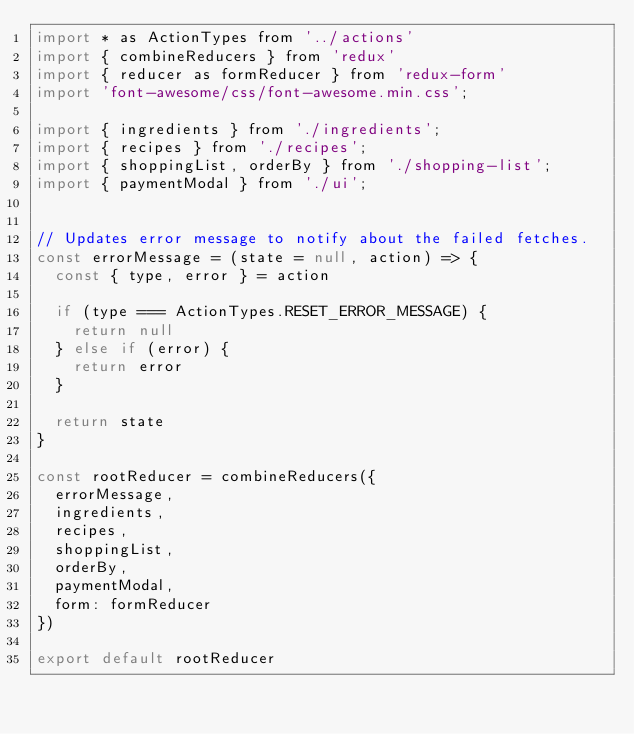<code> <loc_0><loc_0><loc_500><loc_500><_JavaScript_>import * as ActionTypes from '../actions'
import { combineReducers } from 'redux'
import { reducer as formReducer } from 'redux-form'
import 'font-awesome/css/font-awesome.min.css';

import { ingredients } from './ingredients';
import { recipes } from './recipes';
import { shoppingList, orderBy } from './shopping-list';
import { paymentModal } from './ui';


// Updates error message to notify about the failed fetches.
const errorMessage = (state = null, action) => {
  const { type, error } = action

  if (type === ActionTypes.RESET_ERROR_MESSAGE) {
    return null
  } else if (error) {
    return error
  }

  return state
}

const rootReducer = combineReducers({
  errorMessage, 
  ingredients,
  recipes,
  shoppingList,
  orderBy,
  paymentModal,
  form: formReducer
})

export default rootReducer</code> 